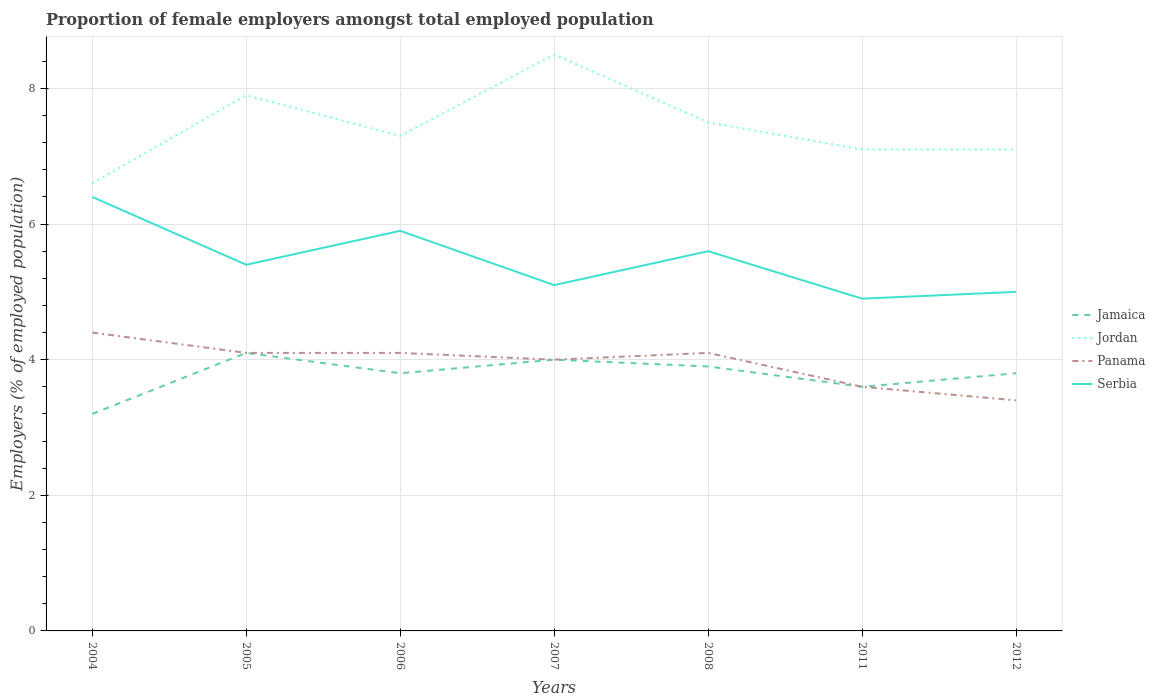Does the line corresponding to Panama intersect with the line corresponding to Jordan?
Keep it short and to the point. No. Across all years, what is the maximum proportion of female employers in Jamaica?
Your response must be concise. 3.2. In which year was the proportion of female employers in Panama maximum?
Keep it short and to the point. 2012. What is the total proportion of female employers in Serbia in the graph?
Your answer should be compact. -0.5. What is the difference between the highest and the second highest proportion of female employers in Jordan?
Offer a very short reply. 1.9. What is the difference between the highest and the lowest proportion of female employers in Panama?
Give a very brief answer. 5. How many years are there in the graph?
Offer a terse response. 7. What is the difference between two consecutive major ticks on the Y-axis?
Offer a very short reply. 2. Does the graph contain any zero values?
Keep it short and to the point. No. Does the graph contain grids?
Your answer should be very brief. Yes. How many legend labels are there?
Keep it short and to the point. 4. What is the title of the graph?
Ensure brevity in your answer.  Proportion of female employers amongst total employed population. What is the label or title of the X-axis?
Your response must be concise. Years. What is the label or title of the Y-axis?
Ensure brevity in your answer.  Employers (% of employed population). What is the Employers (% of employed population) in Jamaica in 2004?
Provide a short and direct response. 3.2. What is the Employers (% of employed population) in Jordan in 2004?
Make the answer very short. 6.6. What is the Employers (% of employed population) of Panama in 2004?
Your answer should be compact. 4.4. What is the Employers (% of employed population) of Serbia in 2004?
Ensure brevity in your answer.  6.4. What is the Employers (% of employed population) of Jamaica in 2005?
Your response must be concise. 4.1. What is the Employers (% of employed population) in Jordan in 2005?
Make the answer very short. 7.9. What is the Employers (% of employed population) of Panama in 2005?
Keep it short and to the point. 4.1. What is the Employers (% of employed population) of Serbia in 2005?
Offer a terse response. 5.4. What is the Employers (% of employed population) in Jamaica in 2006?
Provide a short and direct response. 3.8. What is the Employers (% of employed population) in Jordan in 2006?
Give a very brief answer. 7.3. What is the Employers (% of employed population) of Panama in 2006?
Your answer should be compact. 4.1. What is the Employers (% of employed population) in Serbia in 2006?
Your answer should be compact. 5.9. What is the Employers (% of employed population) of Jordan in 2007?
Your response must be concise. 8.5. What is the Employers (% of employed population) in Panama in 2007?
Ensure brevity in your answer.  4. What is the Employers (% of employed population) of Serbia in 2007?
Make the answer very short. 5.1. What is the Employers (% of employed population) of Jamaica in 2008?
Keep it short and to the point. 3.9. What is the Employers (% of employed population) in Panama in 2008?
Your response must be concise. 4.1. What is the Employers (% of employed population) of Serbia in 2008?
Make the answer very short. 5.6. What is the Employers (% of employed population) of Jamaica in 2011?
Provide a short and direct response. 3.6. What is the Employers (% of employed population) in Jordan in 2011?
Your answer should be very brief. 7.1. What is the Employers (% of employed population) in Panama in 2011?
Provide a short and direct response. 3.6. What is the Employers (% of employed population) of Serbia in 2011?
Provide a short and direct response. 4.9. What is the Employers (% of employed population) in Jamaica in 2012?
Offer a very short reply. 3.8. What is the Employers (% of employed population) in Jordan in 2012?
Give a very brief answer. 7.1. What is the Employers (% of employed population) of Panama in 2012?
Offer a terse response. 3.4. Across all years, what is the maximum Employers (% of employed population) in Jamaica?
Ensure brevity in your answer.  4.1. Across all years, what is the maximum Employers (% of employed population) of Jordan?
Make the answer very short. 8.5. Across all years, what is the maximum Employers (% of employed population) in Panama?
Offer a very short reply. 4.4. Across all years, what is the maximum Employers (% of employed population) of Serbia?
Offer a terse response. 6.4. Across all years, what is the minimum Employers (% of employed population) in Jamaica?
Offer a very short reply. 3.2. Across all years, what is the minimum Employers (% of employed population) of Jordan?
Offer a terse response. 6.6. Across all years, what is the minimum Employers (% of employed population) in Panama?
Make the answer very short. 3.4. Across all years, what is the minimum Employers (% of employed population) in Serbia?
Offer a terse response. 4.9. What is the total Employers (% of employed population) in Jamaica in the graph?
Offer a terse response. 26.4. What is the total Employers (% of employed population) of Panama in the graph?
Make the answer very short. 27.7. What is the total Employers (% of employed population) of Serbia in the graph?
Offer a very short reply. 38.3. What is the difference between the Employers (% of employed population) of Jamaica in 2004 and that in 2005?
Ensure brevity in your answer.  -0.9. What is the difference between the Employers (% of employed population) of Jordan in 2004 and that in 2005?
Keep it short and to the point. -1.3. What is the difference between the Employers (% of employed population) in Serbia in 2004 and that in 2005?
Keep it short and to the point. 1. What is the difference between the Employers (% of employed population) in Jamaica in 2004 and that in 2006?
Make the answer very short. -0.6. What is the difference between the Employers (% of employed population) of Jordan in 2004 and that in 2006?
Your answer should be compact. -0.7. What is the difference between the Employers (% of employed population) of Serbia in 2004 and that in 2008?
Your response must be concise. 0.8. What is the difference between the Employers (% of employed population) of Jamaica in 2004 and that in 2011?
Ensure brevity in your answer.  -0.4. What is the difference between the Employers (% of employed population) in Jordan in 2004 and that in 2012?
Make the answer very short. -0.5. What is the difference between the Employers (% of employed population) in Serbia in 2004 and that in 2012?
Ensure brevity in your answer.  1.4. What is the difference between the Employers (% of employed population) in Jamaica in 2005 and that in 2006?
Offer a terse response. 0.3. What is the difference between the Employers (% of employed population) of Jordan in 2005 and that in 2006?
Your answer should be compact. 0.6. What is the difference between the Employers (% of employed population) in Panama in 2005 and that in 2006?
Give a very brief answer. 0. What is the difference between the Employers (% of employed population) of Jamaica in 2005 and that in 2007?
Keep it short and to the point. 0.1. What is the difference between the Employers (% of employed population) in Jordan in 2005 and that in 2007?
Offer a very short reply. -0.6. What is the difference between the Employers (% of employed population) in Panama in 2005 and that in 2007?
Your answer should be compact. 0.1. What is the difference between the Employers (% of employed population) in Serbia in 2005 and that in 2007?
Your answer should be very brief. 0.3. What is the difference between the Employers (% of employed population) of Jamaica in 2005 and that in 2008?
Provide a succinct answer. 0.2. What is the difference between the Employers (% of employed population) in Jamaica in 2005 and that in 2011?
Make the answer very short. 0.5. What is the difference between the Employers (% of employed population) in Jordan in 2006 and that in 2007?
Your response must be concise. -1.2. What is the difference between the Employers (% of employed population) in Panama in 2006 and that in 2007?
Offer a terse response. 0.1. What is the difference between the Employers (% of employed population) of Jamaica in 2006 and that in 2008?
Your answer should be compact. -0.1. What is the difference between the Employers (% of employed population) of Jordan in 2006 and that in 2008?
Offer a very short reply. -0.2. What is the difference between the Employers (% of employed population) of Panama in 2006 and that in 2008?
Provide a succinct answer. 0. What is the difference between the Employers (% of employed population) in Serbia in 2006 and that in 2008?
Provide a succinct answer. 0.3. What is the difference between the Employers (% of employed population) of Serbia in 2006 and that in 2011?
Offer a terse response. 1. What is the difference between the Employers (% of employed population) of Serbia in 2006 and that in 2012?
Provide a short and direct response. 0.9. What is the difference between the Employers (% of employed population) of Jamaica in 2007 and that in 2008?
Ensure brevity in your answer.  0.1. What is the difference between the Employers (% of employed population) in Panama in 2007 and that in 2008?
Offer a very short reply. -0.1. What is the difference between the Employers (% of employed population) in Serbia in 2007 and that in 2008?
Provide a succinct answer. -0.5. What is the difference between the Employers (% of employed population) of Jordan in 2007 and that in 2011?
Provide a short and direct response. 1.4. What is the difference between the Employers (% of employed population) of Panama in 2007 and that in 2011?
Give a very brief answer. 0.4. What is the difference between the Employers (% of employed population) in Panama in 2007 and that in 2012?
Your response must be concise. 0.6. What is the difference between the Employers (% of employed population) in Jamaica in 2008 and that in 2011?
Provide a succinct answer. 0.3. What is the difference between the Employers (% of employed population) in Panama in 2008 and that in 2011?
Give a very brief answer. 0.5. What is the difference between the Employers (% of employed population) in Serbia in 2008 and that in 2011?
Ensure brevity in your answer.  0.7. What is the difference between the Employers (% of employed population) of Panama in 2008 and that in 2012?
Offer a terse response. 0.7. What is the difference between the Employers (% of employed population) of Jamaica in 2011 and that in 2012?
Keep it short and to the point. -0.2. What is the difference between the Employers (% of employed population) of Serbia in 2011 and that in 2012?
Provide a short and direct response. -0.1. What is the difference between the Employers (% of employed population) of Jamaica in 2004 and the Employers (% of employed population) of Panama in 2005?
Ensure brevity in your answer.  -0.9. What is the difference between the Employers (% of employed population) of Jordan in 2004 and the Employers (% of employed population) of Serbia in 2005?
Your answer should be very brief. 1.2. What is the difference between the Employers (% of employed population) of Panama in 2004 and the Employers (% of employed population) of Serbia in 2005?
Ensure brevity in your answer.  -1. What is the difference between the Employers (% of employed population) of Jamaica in 2004 and the Employers (% of employed population) of Jordan in 2006?
Give a very brief answer. -4.1. What is the difference between the Employers (% of employed population) in Jamaica in 2004 and the Employers (% of employed population) in Serbia in 2006?
Provide a short and direct response. -2.7. What is the difference between the Employers (% of employed population) in Jordan in 2004 and the Employers (% of employed population) in Panama in 2006?
Offer a terse response. 2.5. What is the difference between the Employers (% of employed population) of Jamaica in 2004 and the Employers (% of employed population) of Jordan in 2007?
Your response must be concise. -5.3. What is the difference between the Employers (% of employed population) of Jamaica in 2004 and the Employers (% of employed population) of Panama in 2007?
Ensure brevity in your answer.  -0.8. What is the difference between the Employers (% of employed population) in Jordan in 2004 and the Employers (% of employed population) in Serbia in 2007?
Your answer should be compact. 1.5. What is the difference between the Employers (% of employed population) of Panama in 2004 and the Employers (% of employed population) of Serbia in 2007?
Offer a very short reply. -0.7. What is the difference between the Employers (% of employed population) of Jamaica in 2004 and the Employers (% of employed population) of Jordan in 2008?
Give a very brief answer. -4.3. What is the difference between the Employers (% of employed population) in Jamaica in 2004 and the Employers (% of employed population) in Panama in 2008?
Ensure brevity in your answer.  -0.9. What is the difference between the Employers (% of employed population) of Jamaica in 2004 and the Employers (% of employed population) of Serbia in 2008?
Give a very brief answer. -2.4. What is the difference between the Employers (% of employed population) in Jamaica in 2004 and the Employers (% of employed population) in Jordan in 2011?
Offer a terse response. -3.9. What is the difference between the Employers (% of employed population) in Jordan in 2004 and the Employers (% of employed population) in Serbia in 2011?
Ensure brevity in your answer.  1.7. What is the difference between the Employers (% of employed population) in Jamaica in 2004 and the Employers (% of employed population) in Jordan in 2012?
Provide a succinct answer. -3.9. What is the difference between the Employers (% of employed population) in Jamaica in 2004 and the Employers (% of employed population) in Panama in 2012?
Your response must be concise. -0.2. What is the difference between the Employers (% of employed population) of Jordan in 2004 and the Employers (% of employed population) of Panama in 2012?
Give a very brief answer. 3.2. What is the difference between the Employers (% of employed population) in Jordan in 2004 and the Employers (% of employed population) in Serbia in 2012?
Provide a short and direct response. 1.6. What is the difference between the Employers (% of employed population) in Panama in 2004 and the Employers (% of employed population) in Serbia in 2012?
Keep it short and to the point. -0.6. What is the difference between the Employers (% of employed population) in Jamaica in 2005 and the Employers (% of employed population) in Jordan in 2006?
Your response must be concise. -3.2. What is the difference between the Employers (% of employed population) of Jamaica in 2005 and the Employers (% of employed population) of Panama in 2006?
Make the answer very short. 0. What is the difference between the Employers (% of employed population) of Jamaica in 2005 and the Employers (% of employed population) of Serbia in 2006?
Your answer should be compact. -1.8. What is the difference between the Employers (% of employed population) in Jamaica in 2005 and the Employers (% of employed population) in Serbia in 2007?
Offer a very short reply. -1. What is the difference between the Employers (% of employed population) in Jamaica in 2005 and the Employers (% of employed population) in Panama in 2008?
Offer a very short reply. 0. What is the difference between the Employers (% of employed population) in Jamaica in 2005 and the Employers (% of employed population) in Serbia in 2008?
Your response must be concise. -1.5. What is the difference between the Employers (% of employed population) in Jordan in 2005 and the Employers (% of employed population) in Serbia in 2008?
Provide a short and direct response. 2.3. What is the difference between the Employers (% of employed population) in Jamaica in 2005 and the Employers (% of employed population) in Jordan in 2011?
Ensure brevity in your answer.  -3. What is the difference between the Employers (% of employed population) in Jamaica in 2005 and the Employers (% of employed population) in Serbia in 2011?
Provide a short and direct response. -0.8. What is the difference between the Employers (% of employed population) in Jordan in 2005 and the Employers (% of employed population) in Panama in 2011?
Offer a terse response. 4.3. What is the difference between the Employers (% of employed population) in Jordan in 2005 and the Employers (% of employed population) in Serbia in 2011?
Provide a succinct answer. 3. What is the difference between the Employers (% of employed population) of Panama in 2005 and the Employers (% of employed population) of Serbia in 2011?
Your answer should be compact. -0.8. What is the difference between the Employers (% of employed population) in Jordan in 2005 and the Employers (% of employed population) in Panama in 2012?
Provide a short and direct response. 4.5. What is the difference between the Employers (% of employed population) of Jordan in 2005 and the Employers (% of employed population) of Serbia in 2012?
Your answer should be very brief. 2.9. What is the difference between the Employers (% of employed population) of Panama in 2005 and the Employers (% of employed population) of Serbia in 2012?
Make the answer very short. -0.9. What is the difference between the Employers (% of employed population) in Jamaica in 2006 and the Employers (% of employed population) in Panama in 2007?
Offer a very short reply. -0.2. What is the difference between the Employers (% of employed population) of Jamaica in 2006 and the Employers (% of employed population) of Serbia in 2007?
Your answer should be very brief. -1.3. What is the difference between the Employers (% of employed population) of Jordan in 2006 and the Employers (% of employed population) of Serbia in 2007?
Provide a short and direct response. 2.2. What is the difference between the Employers (% of employed population) in Panama in 2006 and the Employers (% of employed population) in Serbia in 2007?
Make the answer very short. -1. What is the difference between the Employers (% of employed population) of Jamaica in 2006 and the Employers (% of employed population) of Panama in 2008?
Ensure brevity in your answer.  -0.3. What is the difference between the Employers (% of employed population) in Jordan in 2006 and the Employers (% of employed population) in Panama in 2008?
Give a very brief answer. 3.2. What is the difference between the Employers (% of employed population) in Panama in 2006 and the Employers (% of employed population) in Serbia in 2008?
Ensure brevity in your answer.  -1.5. What is the difference between the Employers (% of employed population) of Jamaica in 2006 and the Employers (% of employed population) of Jordan in 2011?
Provide a succinct answer. -3.3. What is the difference between the Employers (% of employed population) in Jamaica in 2006 and the Employers (% of employed population) in Panama in 2011?
Keep it short and to the point. 0.2. What is the difference between the Employers (% of employed population) of Jordan in 2006 and the Employers (% of employed population) of Panama in 2011?
Provide a succinct answer. 3.7. What is the difference between the Employers (% of employed population) of Jamaica in 2006 and the Employers (% of employed population) of Jordan in 2012?
Provide a succinct answer. -3.3. What is the difference between the Employers (% of employed population) of Jamaica in 2006 and the Employers (% of employed population) of Panama in 2012?
Give a very brief answer. 0.4. What is the difference between the Employers (% of employed population) of Jordan in 2006 and the Employers (% of employed population) of Serbia in 2012?
Make the answer very short. 2.3. What is the difference between the Employers (% of employed population) in Panama in 2006 and the Employers (% of employed population) in Serbia in 2012?
Provide a succinct answer. -0.9. What is the difference between the Employers (% of employed population) of Jamaica in 2007 and the Employers (% of employed population) of Panama in 2008?
Your response must be concise. -0.1. What is the difference between the Employers (% of employed population) in Jamaica in 2007 and the Employers (% of employed population) in Serbia in 2008?
Ensure brevity in your answer.  -1.6. What is the difference between the Employers (% of employed population) in Jordan in 2007 and the Employers (% of employed population) in Serbia in 2008?
Your answer should be compact. 2.9. What is the difference between the Employers (% of employed population) in Panama in 2007 and the Employers (% of employed population) in Serbia in 2008?
Offer a terse response. -1.6. What is the difference between the Employers (% of employed population) of Jamaica in 2007 and the Employers (% of employed population) of Panama in 2011?
Offer a very short reply. 0.4. What is the difference between the Employers (% of employed population) in Jamaica in 2007 and the Employers (% of employed population) in Serbia in 2011?
Provide a succinct answer. -0.9. What is the difference between the Employers (% of employed population) in Jordan in 2007 and the Employers (% of employed population) in Panama in 2011?
Your answer should be very brief. 4.9. What is the difference between the Employers (% of employed population) of Panama in 2007 and the Employers (% of employed population) of Serbia in 2011?
Your response must be concise. -0.9. What is the difference between the Employers (% of employed population) in Jordan in 2007 and the Employers (% of employed population) in Panama in 2012?
Provide a short and direct response. 5.1. What is the difference between the Employers (% of employed population) of Jamaica in 2008 and the Employers (% of employed population) of Panama in 2011?
Your answer should be very brief. 0.3. What is the difference between the Employers (% of employed population) in Jamaica in 2008 and the Employers (% of employed population) in Serbia in 2011?
Make the answer very short. -1. What is the difference between the Employers (% of employed population) in Jordan in 2008 and the Employers (% of employed population) in Panama in 2011?
Provide a short and direct response. 3.9. What is the difference between the Employers (% of employed population) in Jordan in 2008 and the Employers (% of employed population) in Serbia in 2011?
Your answer should be very brief. 2.6. What is the difference between the Employers (% of employed population) of Jamaica in 2008 and the Employers (% of employed population) of Panama in 2012?
Your answer should be compact. 0.5. What is the difference between the Employers (% of employed population) of Jamaica in 2008 and the Employers (% of employed population) of Serbia in 2012?
Give a very brief answer. -1.1. What is the difference between the Employers (% of employed population) in Jordan in 2008 and the Employers (% of employed population) in Panama in 2012?
Make the answer very short. 4.1. What is the difference between the Employers (% of employed population) in Jordan in 2008 and the Employers (% of employed population) in Serbia in 2012?
Your answer should be compact. 2.5. What is the difference between the Employers (% of employed population) in Panama in 2008 and the Employers (% of employed population) in Serbia in 2012?
Your answer should be compact. -0.9. What is the difference between the Employers (% of employed population) of Jamaica in 2011 and the Employers (% of employed population) of Jordan in 2012?
Give a very brief answer. -3.5. What is the difference between the Employers (% of employed population) in Jamaica in 2011 and the Employers (% of employed population) in Panama in 2012?
Ensure brevity in your answer.  0.2. What is the difference between the Employers (% of employed population) of Jamaica in 2011 and the Employers (% of employed population) of Serbia in 2012?
Your response must be concise. -1.4. What is the difference between the Employers (% of employed population) in Panama in 2011 and the Employers (% of employed population) in Serbia in 2012?
Your answer should be compact. -1.4. What is the average Employers (% of employed population) in Jamaica per year?
Your answer should be very brief. 3.77. What is the average Employers (% of employed population) in Jordan per year?
Give a very brief answer. 7.43. What is the average Employers (% of employed population) in Panama per year?
Your answer should be compact. 3.96. What is the average Employers (% of employed population) in Serbia per year?
Make the answer very short. 5.47. In the year 2004, what is the difference between the Employers (% of employed population) in Jamaica and Employers (% of employed population) in Jordan?
Your response must be concise. -3.4. In the year 2004, what is the difference between the Employers (% of employed population) in Jamaica and Employers (% of employed population) in Panama?
Your answer should be compact. -1.2. In the year 2004, what is the difference between the Employers (% of employed population) in Jamaica and Employers (% of employed population) in Serbia?
Provide a short and direct response. -3.2. In the year 2004, what is the difference between the Employers (% of employed population) of Jordan and Employers (% of employed population) of Panama?
Provide a succinct answer. 2.2. In the year 2005, what is the difference between the Employers (% of employed population) in Jamaica and Employers (% of employed population) in Jordan?
Your response must be concise. -3.8. In the year 2005, what is the difference between the Employers (% of employed population) of Jamaica and Employers (% of employed population) of Serbia?
Provide a short and direct response. -1.3. In the year 2005, what is the difference between the Employers (% of employed population) of Jordan and Employers (% of employed population) of Panama?
Give a very brief answer. 3.8. In the year 2005, what is the difference between the Employers (% of employed population) of Jordan and Employers (% of employed population) of Serbia?
Give a very brief answer. 2.5. In the year 2006, what is the difference between the Employers (% of employed population) in Jamaica and Employers (% of employed population) in Jordan?
Keep it short and to the point. -3.5. In the year 2006, what is the difference between the Employers (% of employed population) of Jamaica and Employers (% of employed population) of Panama?
Offer a terse response. -0.3. In the year 2006, what is the difference between the Employers (% of employed population) in Jordan and Employers (% of employed population) in Panama?
Offer a terse response. 3.2. In the year 2007, what is the difference between the Employers (% of employed population) of Jamaica and Employers (% of employed population) of Jordan?
Ensure brevity in your answer.  -4.5. In the year 2007, what is the difference between the Employers (% of employed population) in Jamaica and Employers (% of employed population) in Panama?
Your response must be concise. 0. In the year 2007, what is the difference between the Employers (% of employed population) of Jamaica and Employers (% of employed population) of Serbia?
Ensure brevity in your answer.  -1.1. In the year 2007, what is the difference between the Employers (% of employed population) in Jordan and Employers (% of employed population) in Serbia?
Give a very brief answer. 3.4. In the year 2007, what is the difference between the Employers (% of employed population) in Panama and Employers (% of employed population) in Serbia?
Your answer should be compact. -1.1. In the year 2008, what is the difference between the Employers (% of employed population) of Jamaica and Employers (% of employed population) of Serbia?
Provide a succinct answer. -1.7. In the year 2008, what is the difference between the Employers (% of employed population) in Jordan and Employers (% of employed population) in Serbia?
Provide a succinct answer. 1.9. In the year 2008, what is the difference between the Employers (% of employed population) in Panama and Employers (% of employed population) in Serbia?
Your response must be concise. -1.5. In the year 2011, what is the difference between the Employers (% of employed population) in Jamaica and Employers (% of employed population) in Panama?
Ensure brevity in your answer.  0. In the year 2011, what is the difference between the Employers (% of employed population) in Jamaica and Employers (% of employed population) in Serbia?
Ensure brevity in your answer.  -1.3. In the year 2011, what is the difference between the Employers (% of employed population) in Jordan and Employers (% of employed population) in Panama?
Provide a succinct answer. 3.5. In the year 2011, what is the difference between the Employers (% of employed population) in Jordan and Employers (% of employed population) in Serbia?
Offer a very short reply. 2.2. In the year 2012, what is the difference between the Employers (% of employed population) in Jamaica and Employers (% of employed population) in Serbia?
Provide a short and direct response. -1.2. In the year 2012, what is the difference between the Employers (% of employed population) of Jordan and Employers (% of employed population) of Serbia?
Your response must be concise. 2.1. In the year 2012, what is the difference between the Employers (% of employed population) of Panama and Employers (% of employed population) of Serbia?
Your response must be concise. -1.6. What is the ratio of the Employers (% of employed population) of Jamaica in 2004 to that in 2005?
Make the answer very short. 0.78. What is the ratio of the Employers (% of employed population) of Jordan in 2004 to that in 2005?
Give a very brief answer. 0.84. What is the ratio of the Employers (% of employed population) in Panama in 2004 to that in 2005?
Ensure brevity in your answer.  1.07. What is the ratio of the Employers (% of employed population) in Serbia in 2004 to that in 2005?
Offer a very short reply. 1.19. What is the ratio of the Employers (% of employed population) in Jamaica in 2004 to that in 2006?
Your answer should be compact. 0.84. What is the ratio of the Employers (% of employed population) of Jordan in 2004 to that in 2006?
Your answer should be compact. 0.9. What is the ratio of the Employers (% of employed population) of Panama in 2004 to that in 2006?
Make the answer very short. 1.07. What is the ratio of the Employers (% of employed population) in Serbia in 2004 to that in 2006?
Your answer should be compact. 1.08. What is the ratio of the Employers (% of employed population) of Jordan in 2004 to that in 2007?
Keep it short and to the point. 0.78. What is the ratio of the Employers (% of employed population) in Serbia in 2004 to that in 2007?
Offer a very short reply. 1.25. What is the ratio of the Employers (% of employed population) in Jamaica in 2004 to that in 2008?
Offer a very short reply. 0.82. What is the ratio of the Employers (% of employed population) in Panama in 2004 to that in 2008?
Offer a very short reply. 1.07. What is the ratio of the Employers (% of employed population) of Jamaica in 2004 to that in 2011?
Offer a terse response. 0.89. What is the ratio of the Employers (% of employed population) of Jordan in 2004 to that in 2011?
Keep it short and to the point. 0.93. What is the ratio of the Employers (% of employed population) in Panama in 2004 to that in 2011?
Ensure brevity in your answer.  1.22. What is the ratio of the Employers (% of employed population) of Serbia in 2004 to that in 2011?
Your answer should be compact. 1.31. What is the ratio of the Employers (% of employed population) of Jamaica in 2004 to that in 2012?
Your answer should be very brief. 0.84. What is the ratio of the Employers (% of employed population) in Jordan in 2004 to that in 2012?
Offer a very short reply. 0.93. What is the ratio of the Employers (% of employed population) in Panama in 2004 to that in 2012?
Offer a terse response. 1.29. What is the ratio of the Employers (% of employed population) of Serbia in 2004 to that in 2012?
Keep it short and to the point. 1.28. What is the ratio of the Employers (% of employed population) in Jamaica in 2005 to that in 2006?
Offer a terse response. 1.08. What is the ratio of the Employers (% of employed population) of Jordan in 2005 to that in 2006?
Your answer should be very brief. 1.08. What is the ratio of the Employers (% of employed population) of Serbia in 2005 to that in 2006?
Ensure brevity in your answer.  0.92. What is the ratio of the Employers (% of employed population) in Jamaica in 2005 to that in 2007?
Give a very brief answer. 1.02. What is the ratio of the Employers (% of employed population) of Jordan in 2005 to that in 2007?
Your answer should be compact. 0.93. What is the ratio of the Employers (% of employed population) in Panama in 2005 to that in 2007?
Ensure brevity in your answer.  1.02. What is the ratio of the Employers (% of employed population) of Serbia in 2005 to that in 2007?
Your answer should be very brief. 1.06. What is the ratio of the Employers (% of employed population) in Jamaica in 2005 to that in 2008?
Your answer should be very brief. 1.05. What is the ratio of the Employers (% of employed population) in Jordan in 2005 to that in 2008?
Provide a succinct answer. 1.05. What is the ratio of the Employers (% of employed population) in Panama in 2005 to that in 2008?
Provide a succinct answer. 1. What is the ratio of the Employers (% of employed population) in Jamaica in 2005 to that in 2011?
Your answer should be very brief. 1.14. What is the ratio of the Employers (% of employed population) of Jordan in 2005 to that in 2011?
Ensure brevity in your answer.  1.11. What is the ratio of the Employers (% of employed population) of Panama in 2005 to that in 2011?
Make the answer very short. 1.14. What is the ratio of the Employers (% of employed population) in Serbia in 2005 to that in 2011?
Offer a very short reply. 1.1. What is the ratio of the Employers (% of employed population) in Jamaica in 2005 to that in 2012?
Keep it short and to the point. 1.08. What is the ratio of the Employers (% of employed population) of Jordan in 2005 to that in 2012?
Ensure brevity in your answer.  1.11. What is the ratio of the Employers (% of employed population) in Panama in 2005 to that in 2012?
Your answer should be compact. 1.21. What is the ratio of the Employers (% of employed population) in Jamaica in 2006 to that in 2007?
Your answer should be compact. 0.95. What is the ratio of the Employers (% of employed population) in Jordan in 2006 to that in 2007?
Your answer should be compact. 0.86. What is the ratio of the Employers (% of employed population) in Serbia in 2006 to that in 2007?
Your response must be concise. 1.16. What is the ratio of the Employers (% of employed population) of Jamaica in 2006 to that in 2008?
Provide a short and direct response. 0.97. What is the ratio of the Employers (% of employed population) of Jordan in 2006 to that in 2008?
Keep it short and to the point. 0.97. What is the ratio of the Employers (% of employed population) of Serbia in 2006 to that in 2008?
Keep it short and to the point. 1.05. What is the ratio of the Employers (% of employed population) in Jamaica in 2006 to that in 2011?
Give a very brief answer. 1.06. What is the ratio of the Employers (% of employed population) in Jordan in 2006 to that in 2011?
Keep it short and to the point. 1.03. What is the ratio of the Employers (% of employed population) in Panama in 2006 to that in 2011?
Keep it short and to the point. 1.14. What is the ratio of the Employers (% of employed population) in Serbia in 2006 to that in 2011?
Provide a succinct answer. 1.2. What is the ratio of the Employers (% of employed population) in Jordan in 2006 to that in 2012?
Make the answer very short. 1.03. What is the ratio of the Employers (% of employed population) in Panama in 2006 to that in 2012?
Your response must be concise. 1.21. What is the ratio of the Employers (% of employed population) of Serbia in 2006 to that in 2012?
Keep it short and to the point. 1.18. What is the ratio of the Employers (% of employed population) of Jamaica in 2007 to that in 2008?
Your response must be concise. 1.03. What is the ratio of the Employers (% of employed population) in Jordan in 2007 to that in 2008?
Ensure brevity in your answer.  1.13. What is the ratio of the Employers (% of employed population) of Panama in 2007 to that in 2008?
Your response must be concise. 0.98. What is the ratio of the Employers (% of employed population) in Serbia in 2007 to that in 2008?
Offer a very short reply. 0.91. What is the ratio of the Employers (% of employed population) of Jordan in 2007 to that in 2011?
Give a very brief answer. 1.2. What is the ratio of the Employers (% of employed population) in Serbia in 2007 to that in 2011?
Provide a short and direct response. 1.04. What is the ratio of the Employers (% of employed population) in Jamaica in 2007 to that in 2012?
Your answer should be very brief. 1.05. What is the ratio of the Employers (% of employed population) in Jordan in 2007 to that in 2012?
Your answer should be compact. 1.2. What is the ratio of the Employers (% of employed population) of Panama in 2007 to that in 2012?
Give a very brief answer. 1.18. What is the ratio of the Employers (% of employed population) in Serbia in 2007 to that in 2012?
Make the answer very short. 1.02. What is the ratio of the Employers (% of employed population) in Jordan in 2008 to that in 2011?
Provide a succinct answer. 1.06. What is the ratio of the Employers (% of employed population) in Panama in 2008 to that in 2011?
Offer a terse response. 1.14. What is the ratio of the Employers (% of employed population) of Jamaica in 2008 to that in 2012?
Provide a short and direct response. 1.03. What is the ratio of the Employers (% of employed population) of Jordan in 2008 to that in 2012?
Make the answer very short. 1.06. What is the ratio of the Employers (% of employed population) in Panama in 2008 to that in 2012?
Keep it short and to the point. 1.21. What is the ratio of the Employers (% of employed population) in Serbia in 2008 to that in 2012?
Your answer should be very brief. 1.12. What is the ratio of the Employers (% of employed population) in Jordan in 2011 to that in 2012?
Your response must be concise. 1. What is the ratio of the Employers (% of employed population) in Panama in 2011 to that in 2012?
Provide a succinct answer. 1.06. What is the difference between the highest and the second highest Employers (% of employed population) of Panama?
Provide a short and direct response. 0.3. What is the difference between the highest and the second highest Employers (% of employed population) of Serbia?
Provide a short and direct response. 0.5. What is the difference between the highest and the lowest Employers (% of employed population) of Jamaica?
Keep it short and to the point. 0.9. What is the difference between the highest and the lowest Employers (% of employed population) of Jordan?
Ensure brevity in your answer.  1.9. What is the difference between the highest and the lowest Employers (% of employed population) of Panama?
Your answer should be compact. 1. 